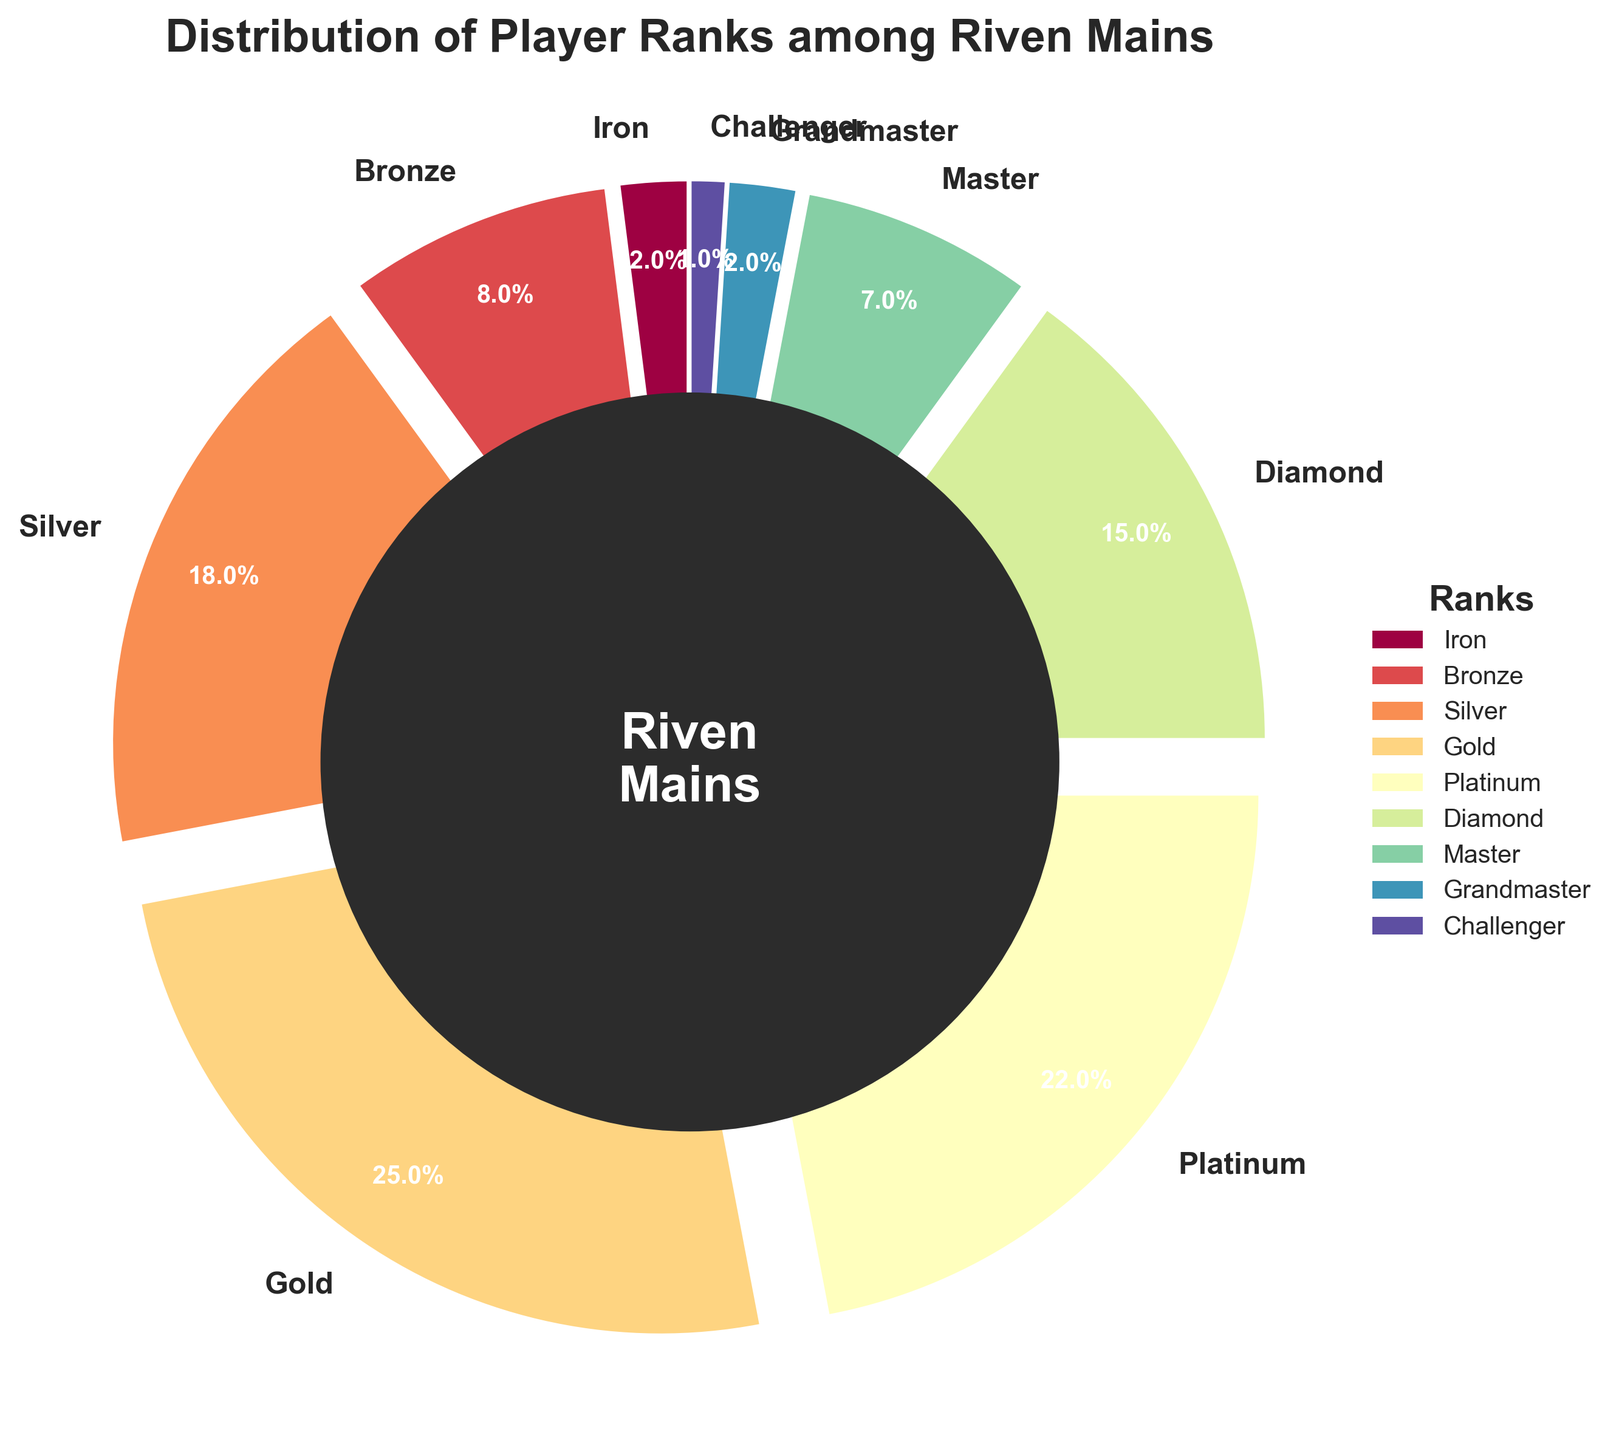What rank represents the largest portion of Riven mains? By looking at the pie chart, we can see which slice occupies the largest area. Gold has the biggest slice, representing 25%.
Answer: Gold How many ranks include more than 20% of Riven mains? The slices for Gold and Platinum are the only ones that exceed 20%.
Answer: 2 Which has a higher percentage, Diamond or Master? By comparing the slices, we see that Diamond has 15% whereas Master has 7%.
Answer: Diamond What is the combined percentage of Silver and Gold ranks together? Silver is 18% and Gold is 25%. Adding them together: 18% + 25% = 43%.
Answer: 43% Is the percentage of Riven mains in Iron greater or lesser than the percentage of Challenger mains? The chart shows Iron at 2% and Challenger at 1%, so Iron is greater.
Answer: Greater What is the difference in percentage between Platinum and Bronze ranks? Platinum is 22% and Bronze is 8%. The difference is 22% - 8% = 14%.
Answer: 14% Are there more Riven mains in the Master rank or in the Iron and Grandmaster ranks combined? Master has 7%. Iron and Grandmaster together have 2% + 2% = 4%. Therefore, Master has more.
Answer: Master What ranks constitute less than 10% of the player base each? Iron, Bronze, Master, Grandmaster, and Challenger each comprise less than 10% as per their respective slices.
Answer: Iron, Bronze, Master, Grandmaster, Challenger Which rank is represented by the fourth largest slice? First looking at Gold, then Platinum, then Silver, the fourth largest slice is Diamond at 15%.
Answer: Diamond What is the average percentage of the Gold, Silver, and Platinum ranks combined? Gold and Silver are 25% and 18% respectively, and Platinum is 22%. Their combined percentage is 25% + 18% + 22% = 65%, and the average is 65% / 3 = approximately 21.67%.
Answer: 21.67% 